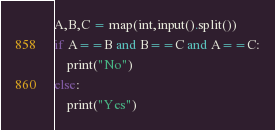<code> <loc_0><loc_0><loc_500><loc_500><_Python_>A,B,C = map(int,input().split())
if A==B and B==C and A==C:
    print("No")
else:
    print("Yes")</code> 